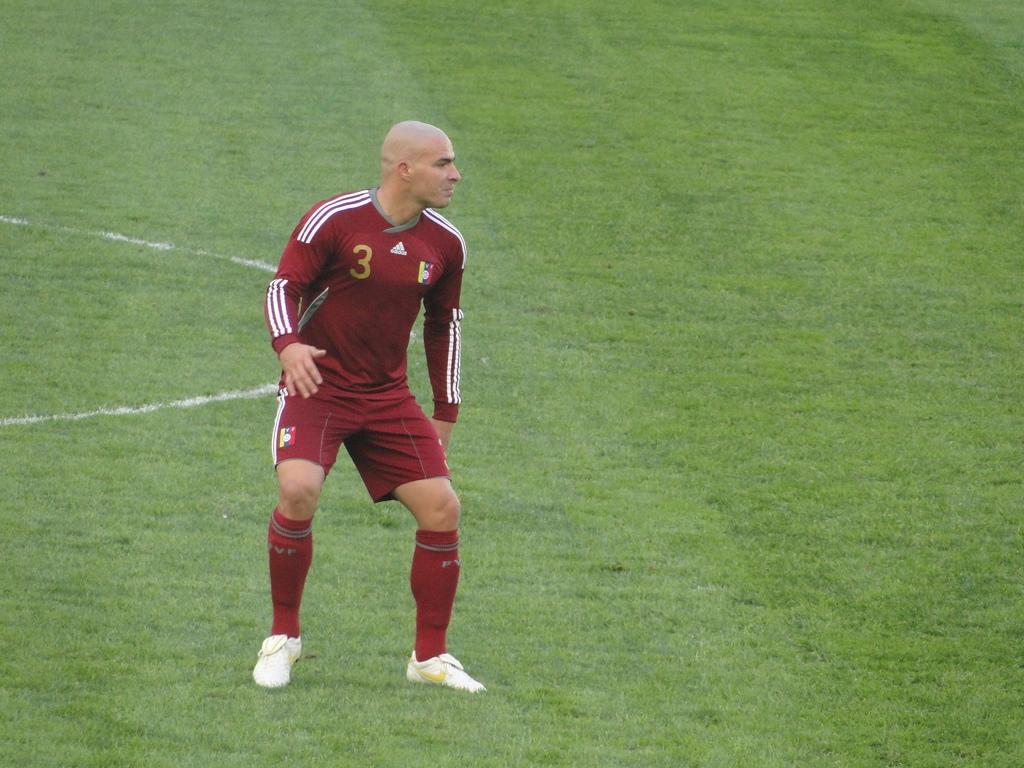How would you summarize this image in a sentence or two? In this image I can see a person is standing and wearing maroon and white color dress and white shoes. He is standing in the ground. 